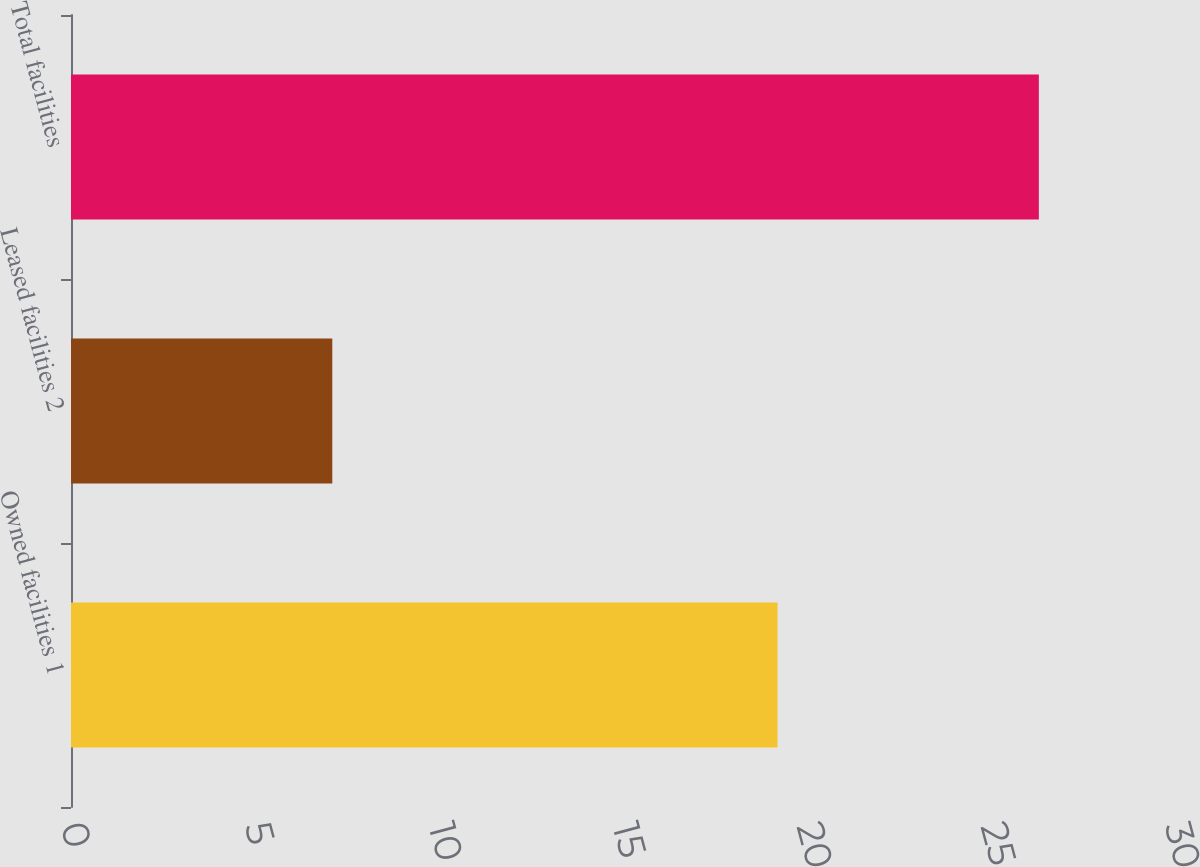Convert chart. <chart><loc_0><loc_0><loc_500><loc_500><bar_chart><fcel>Owned facilities 1<fcel>Leased facilities 2<fcel>Total facilities<nl><fcel>19.2<fcel>7.1<fcel>26.3<nl></chart> 